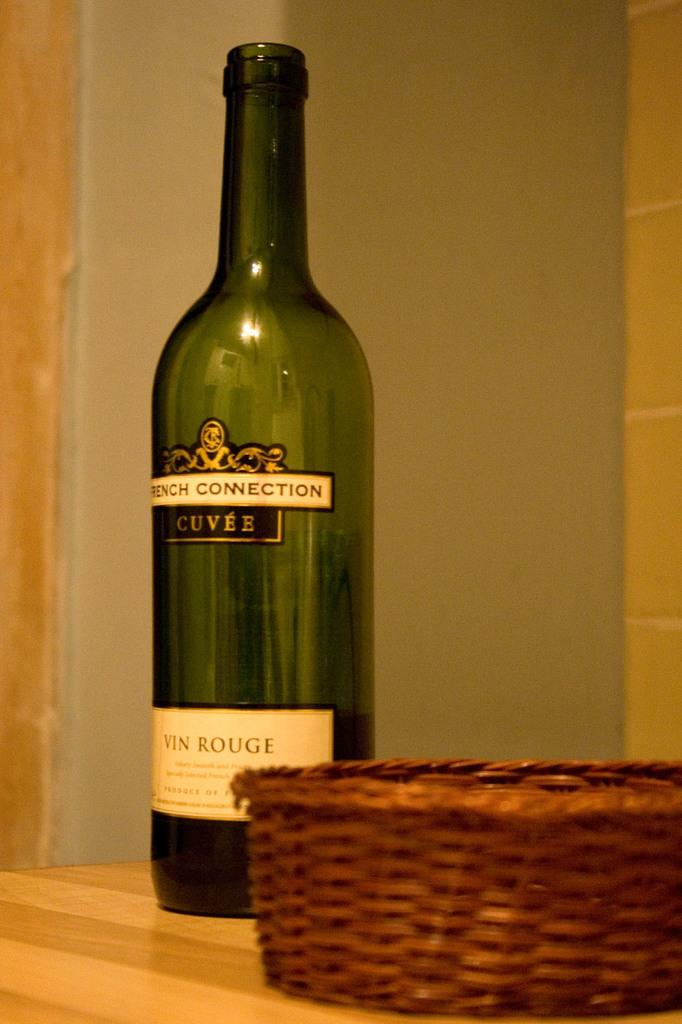<image>
Write a terse but informative summary of the picture. A bottle of wine is labeled FRENCH CONNECTION CUVEE. 